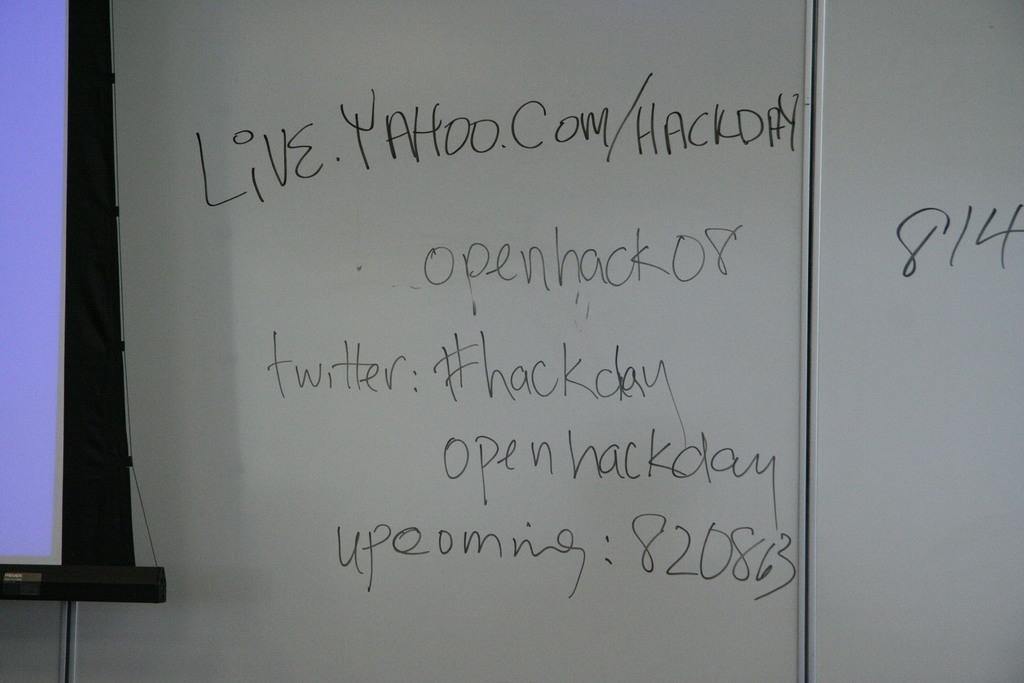<image>
Present a compact description of the photo's key features. A white board with the number 814 written on it. 